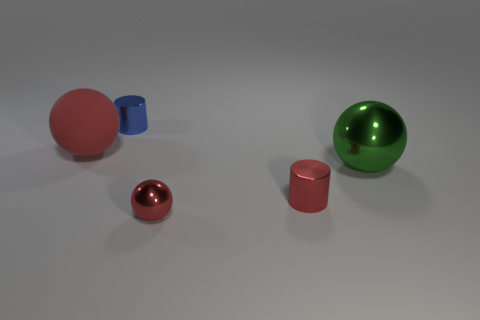Subtract all big green shiny balls. How many balls are left? 2 Subtract all green balls. How many balls are left? 2 Subtract 2 balls. How many balls are left? 1 Add 2 green spheres. How many green spheres are left? 3 Add 2 large green rubber balls. How many large green rubber balls exist? 2 Add 5 small red cylinders. How many objects exist? 10 Subtract 2 red spheres. How many objects are left? 3 Subtract all spheres. How many objects are left? 2 Subtract all cyan spheres. Subtract all gray cylinders. How many spheres are left? 3 Subtract all yellow spheres. How many purple cylinders are left? 0 